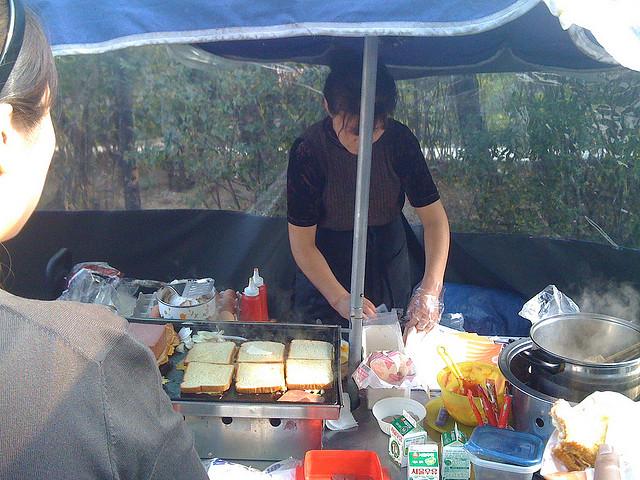What is in the tall red containers near the grill?
Answer briefly. Ketchup. Is this a concession stand?
Write a very short answer. Yes. What is on the grill?
Short answer required. Bread. 